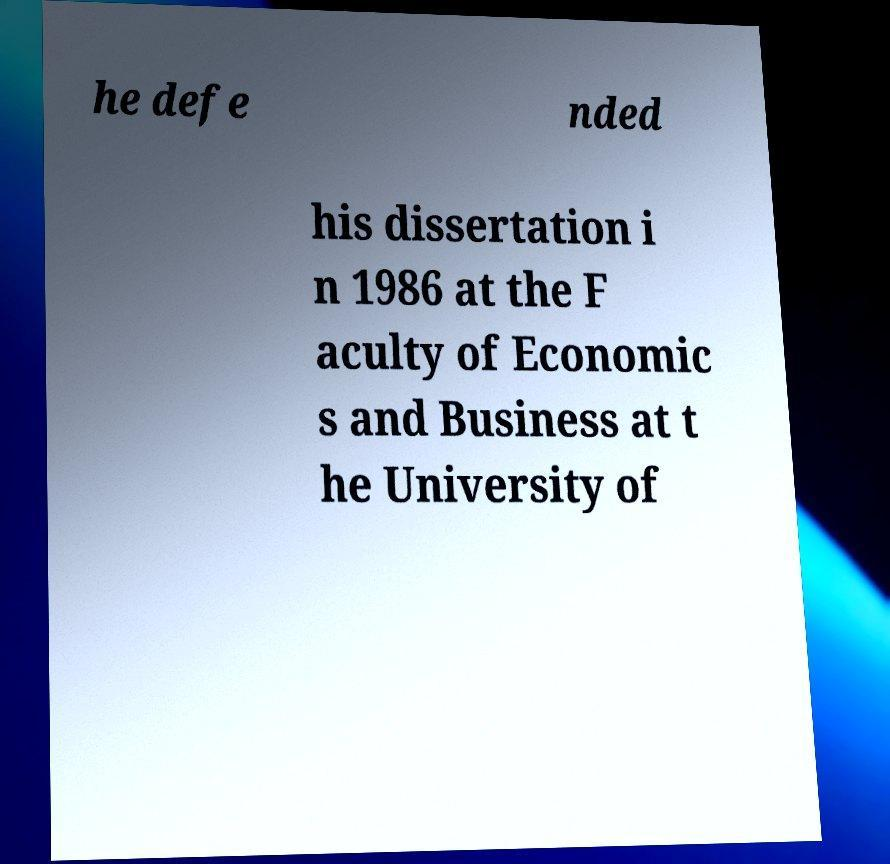Could you extract and type out the text from this image? he defe nded his dissertation i n 1986 at the F aculty of Economic s and Business at t he University of 